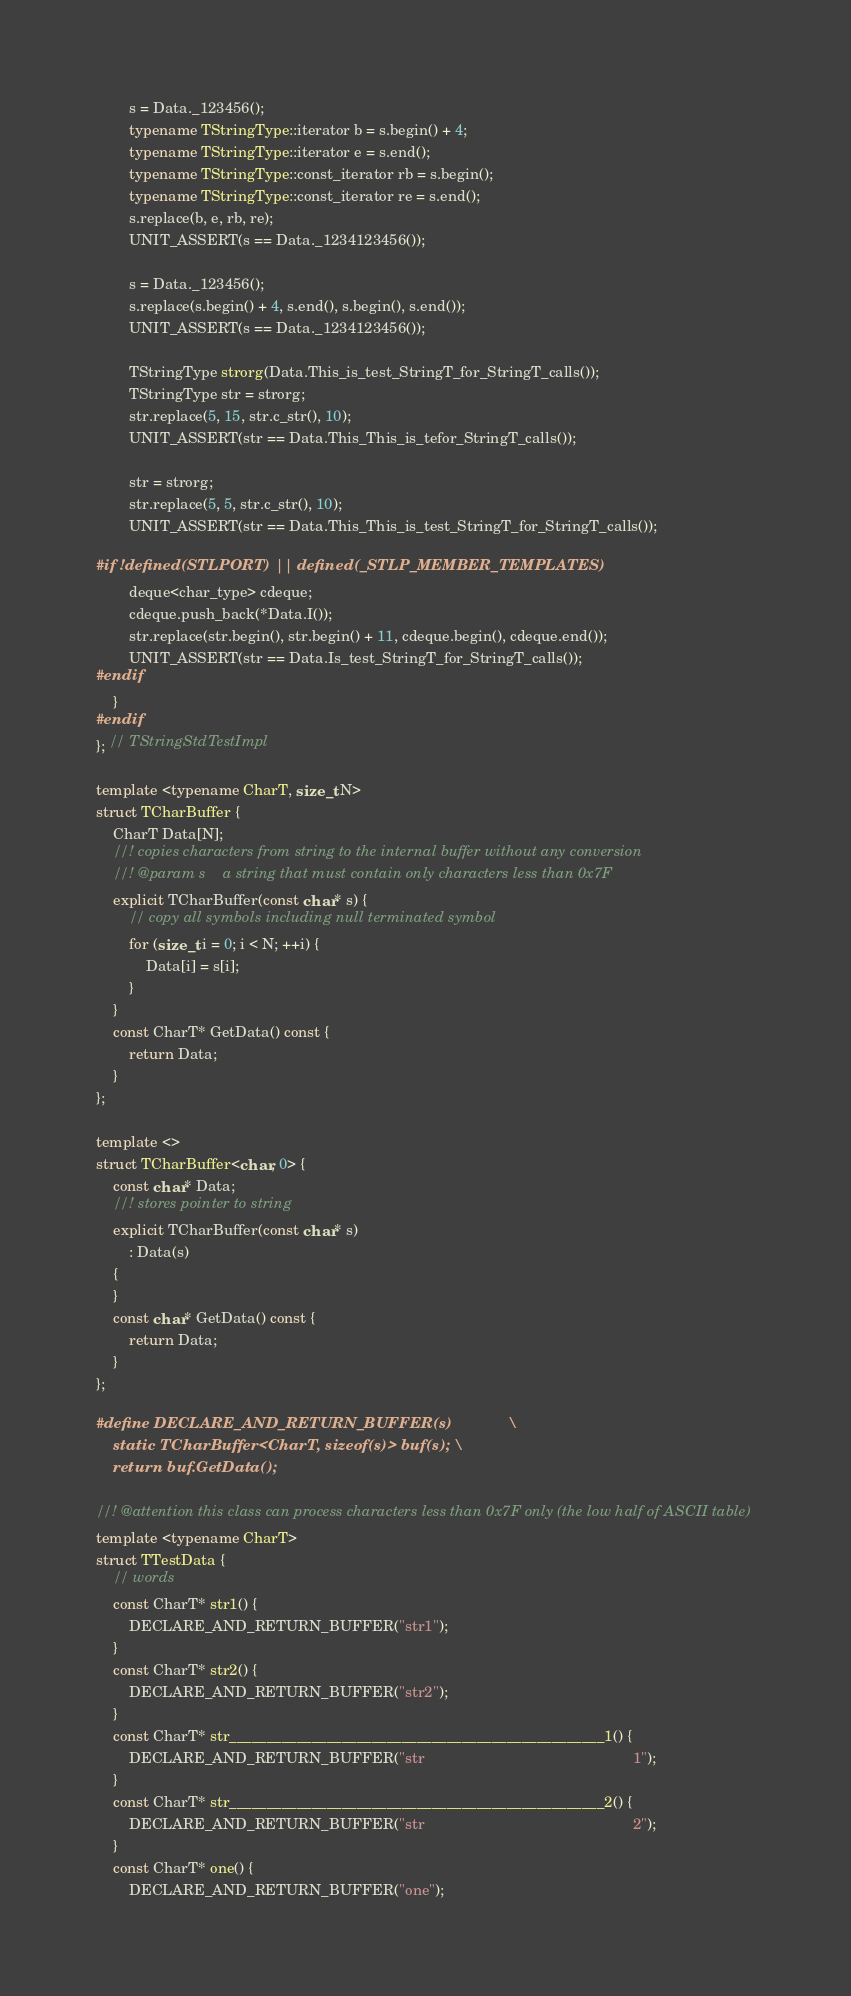Convert code to text. <code><loc_0><loc_0><loc_500><loc_500><_C++_>        s = Data._123456();
        typename TStringType::iterator b = s.begin() + 4;
        typename TStringType::iterator e = s.end();
        typename TStringType::const_iterator rb = s.begin();
        typename TStringType::const_iterator re = s.end();
        s.replace(b, e, rb, re);
        UNIT_ASSERT(s == Data._1234123456());

        s = Data._123456();
        s.replace(s.begin() + 4, s.end(), s.begin(), s.end());
        UNIT_ASSERT(s == Data._1234123456());

        TStringType strorg(Data.This_is_test_StringT_for_StringT_calls());
        TStringType str = strorg;
        str.replace(5, 15, str.c_str(), 10);
        UNIT_ASSERT(str == Data.This_This_is_tefor_StringT_calls());

        str = strorg;
        str.replace(5, 5, str.c_str(), 10);
        UNIT_ASSERT(str == Data.This_This_is_test_StringT_for_StringT_calls());

#if !defined(STLPORT) || defined(_STLP_MEMBER_TEMPLATES)
        deque<char_type> cdeque;
        cdeque.push_back(*Data.I());
        str.replace(str.begin(), str.begin() + 11, cdeque.begin(), cdeque.end());
        UNIT_ASSERT(str == Data.Is_test_StringT_for_StringT_calls());
#endif
    }
#endif
}; // TStringStdTestImpl

template <typename CharT, size_t N>
struct TCharBuffer {
    CharT Data[N];
    //! copies characters from string to the internal buffer without any conversion
    //! @param s    a string that must contain only characters less than 0x7F
    explicit TCharBuffer(const char* s) {
        // copy all symbols including null terminated symbol
        for (size_t i = 0; i < N; ++i) {
            Data[i] = s[i];
        }
    }
    const CharT* GetData() const {
        return Data;
    }
};

template <>
struct TCharBuffer<char, 0> {
    const char* Data;
    //! stores pointer to string
    explicit TCharBuffer(const char* s)
        : Data(s)
    {
    }
    const char* GetData() const {
        return Data;
    }
};

#define DECLARE_AND_RETURN_BUFFER(s)             \
    static TCharBuffer<CharT, sizeof(s)> buf(s); \
    return buf.GetData();

//! @attention this class can process characters less than 0x7F only (the low half of ASCII table)
template <typename CharT>
struct TTestData {
    // words
    const CharT* str1() {
        DECLARE_AND_RETURN_BUFFER("str1");
    }
    const CharT* str2() {
        DECLARE_AND_RETURN_BUFFER("str2");
    }
    const CharT* str__________________________________________________1() {
        DECLARE_AND_RETURN_BUFFER("str                                                  1");
    }
    const CharT* str__________________________________________________2() {
        DECLARE_AND_RETURN_BUFFER("str                                                  2");
    }
    const CharT* one() {
        DECLARE_AND_RETURN_BUFFER("one");</code> 